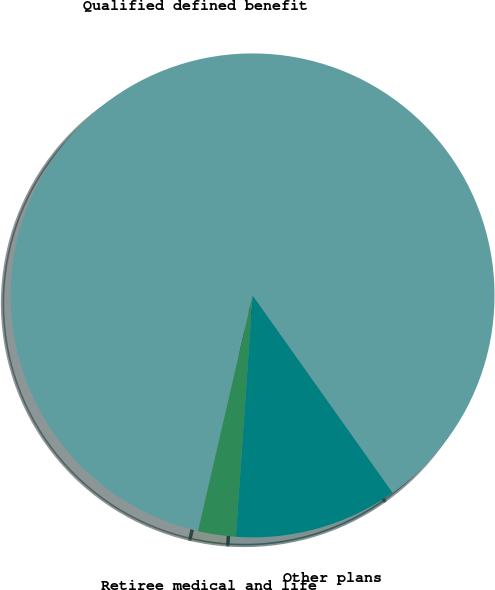<chart> <loc_0><loc_0><loc_500><loc_500><pie_chart><fcel>Qualified defined benefit<fcel>Retiree medical and life<fcel>Other plans<nl><fcel>86.56%<fcel>2.52%<fcel>10.92%<nl></chart> 